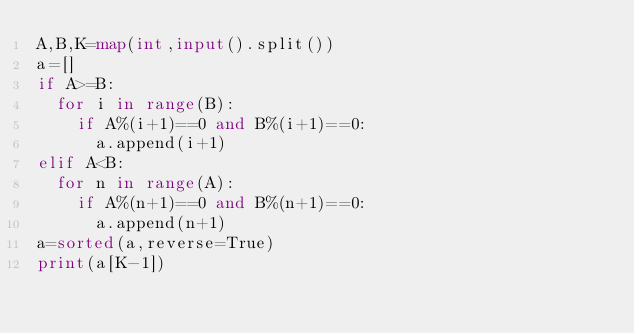<code> <loc_0><loc_0><loc_500><loc_500><_Python_>A,B,K=map(int,input().split())
a=[]
if A>=B:
  for i in range(B):
    if A%(i+1)==0 and B%(i+1)==0:
      a.append(i+1)
elif A<B:
  for n in range(A):
    if A%(n+1)==0 and B%(n+1)==0:
      a.append(n+1)
a=sorted(a,reverse=True)
print(a[K-1])</code> 